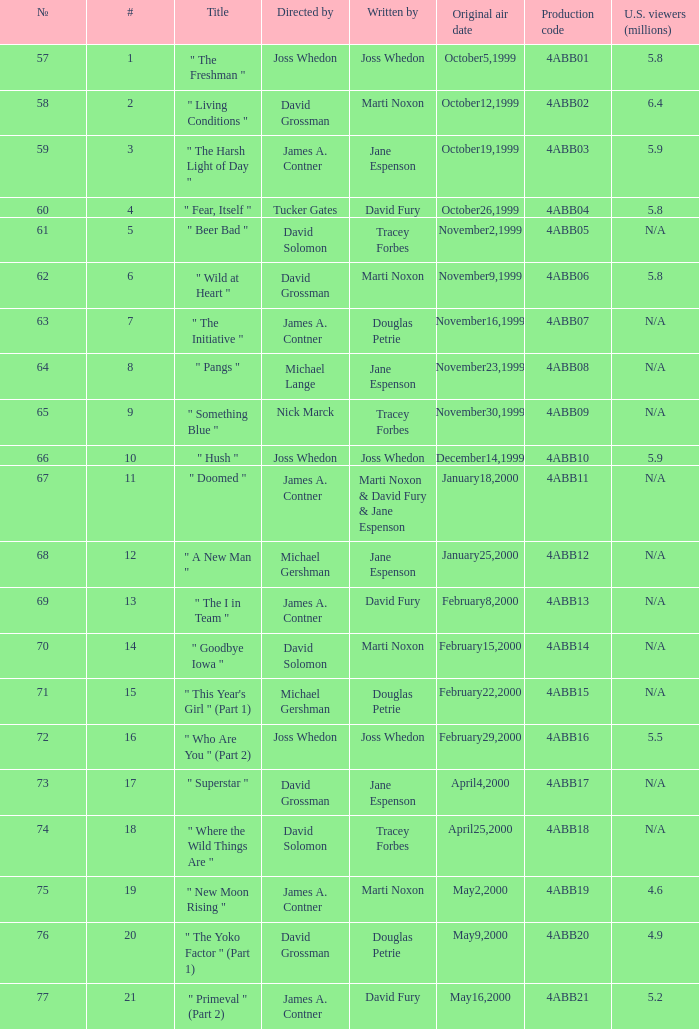What is the production code for the episode with 5.5 million u.s. viewers? 4ABB16. Could you parse the entire table? {'header': ['№', '#', 'Title', 'Directed by', 'Written by', 'Original air date', 'Production code', 'U.S. viewers (millions)'], 'rows': [['57', '1', '" The Freshman "', 'Joss Whedon', 'Joss Whedon', 'October5,1999', '4ABB01', '5.8'], ['58', '2', '" Living Conditions "', 'David Grossman', 'Marti Noxon', 'October12,1999', '4ABB02', '6.4'], ['59', '3', '" The Harsh Light of Day "', 'James A. Contner', 'Jane Espenson', 'October19,1999', '4ABB03', '5.9'], ['60', '4', '" Fear, Itself "', 'Tucker Gates', 'David Fury', 'October26,1999', '4ABB04', '5.8'], ['61', '5', '" Beer Bad "', 'David Solomon', 'Tracey Forbes', 'November2,1999', '4ABB05', 'N/A'], ['62', '6', '" Wild at Heart "', 'David Grossman', 'Marti Noxon', 'November9,1999', '4ABB06', '5.8'], ['63', '7', '" The Initiative "', 'James A. Contner', 'Douglas Petrie', 'November16,1999', '4ABB07', 'N/A'], ['64', '8', '" Pangs "', 'Michael Lange', 'Jane Espenson', 'November23,1999', '4ABB08', 'N/A'], ['65', '9', '" Something Blue "', 'Nick Marck', 'Tracey Forbes', 'November30,1999', '4ABB09', 'N/A'], ['66', '10', '" Hush "', 'Joss Whedon', 'Joss Whedon', 'December14,1999', '4ABB10', '5.9'], ['67', '11', '" Doomed "', 'James A. Contner', 'Marti Noxon & David Fury & Jane Espenson', 'January18,2000', '4ABB11', 'N/A'], ['68', '12', '" A New Man "', 'Michael Gershman', 'Jane Espenson', 'January25,2000', '4ABB12', 'N/A'], ['69', '13', '" The I in Team "', 'James A. Contner', 'David Fury', 'February8,2000', '4ABB13', 'N/A'], ['70', '14', '" Goodbye Iowa "', 'David Solomon', 'Marti Noxon', 'February15,2000', '4ABB14', 'N/A'], ['71', '15', '" This Year\'s Girl " (Part 1)', 'Michael Gershman', 'Douglas Petrie', 'February22,2000', '4ABB15', 'N/A'], ['72', '16', '" Who Are You " (Part 2)', 'Joss Whedon', 'Joss Whedon', 'February29,2000', '4ABB16', '5.5'], ['73', '17', '" Superstar "', 'David Grossman', 'Jane Espenson', 'April4,2000', '4ABB17', 'N/A'], ['74', '18', '" Where the Wild Things Are "', 'David Solomon', 'Tracey Forbes', 'April25,2000', '4ABB18', 'N/A'], ['75', '19', '" New Moon Rising "', 'James A. Contner', 'Marti Noxon', 'May2,2000', '4ABB19', '4.6'], ['76', '20', '" The Yoko Factor " (Part 1)', 'David Grossman', 'Douglas Petrie', 'May9,2000', '4ABB20', '4.9'], ['77', '21', '" Primeval " (Part 2)', 'James A. Contner', 'David Fury', 'May16,2000', '4ABB21', '5.2']]} 